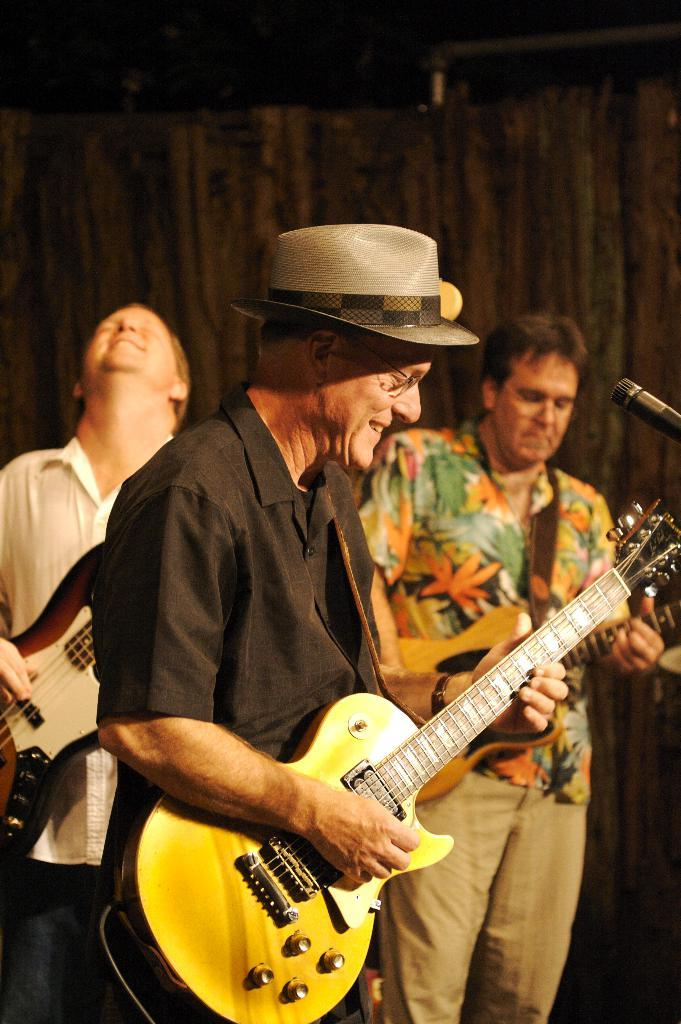How many people are in the image? There are three persons in the image. What are the persons doing in the image? The persons are playing a guitar. Can you describe the appearance of one of the persons? One of the persons is wearing a hat. What other object can be seen in the image? There is a mic in the image. What type of lamp is being used by the farmer in the image? There is no farmer or lamp present in the image. The image features three persons playing a guitar and a mic. 